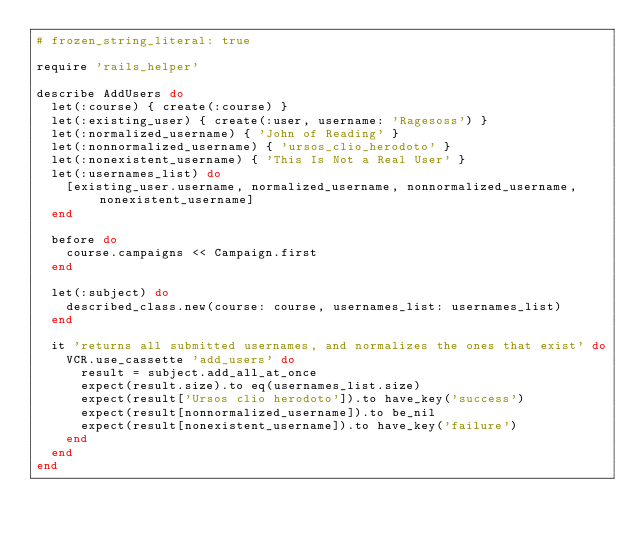Convert code to text. <code><loc_0><loc_0><loc_500><loc_500><_Ruby_># frozen_string_literal: true

require 'rails_helper'

describe AddUsers do
  let(:course) { create(:course) }
  let(:existing_user) { create(:user, username: 'Ragesoss') }
  let(:normalized_username) { 'John of Reading' }
  let(:nonnormalized_username) { 'ursos_clio_herodoto' }
  let(:nonexistent_username) { 'This Is Not a Real User' }
  let(:usernames_list) do
    [existing_user.username, normalized_username, nonnormalized_username, nonexistent_username]
  end

  before do
    course.campaigns << Campaign.first
  end

  let(:subject) do
    described_class.new(course: course, usernames_list: usernames_list)
  end

  it 'returns all submitted usernames, and normalizes the ones that exist' do
    VCR.use_cassette 'add_users' do
      result = subject.add_all_at_once
      expect(result.size).to eq(usernames_list.size)
      expect(result['Ursos clio herodoto']).to have_key('success')
      expect(result[nonnormalized_username]).to be_nil
      expect(result[nonexistent_username]).to have_key('failure')
    end
  end
end
</code> 